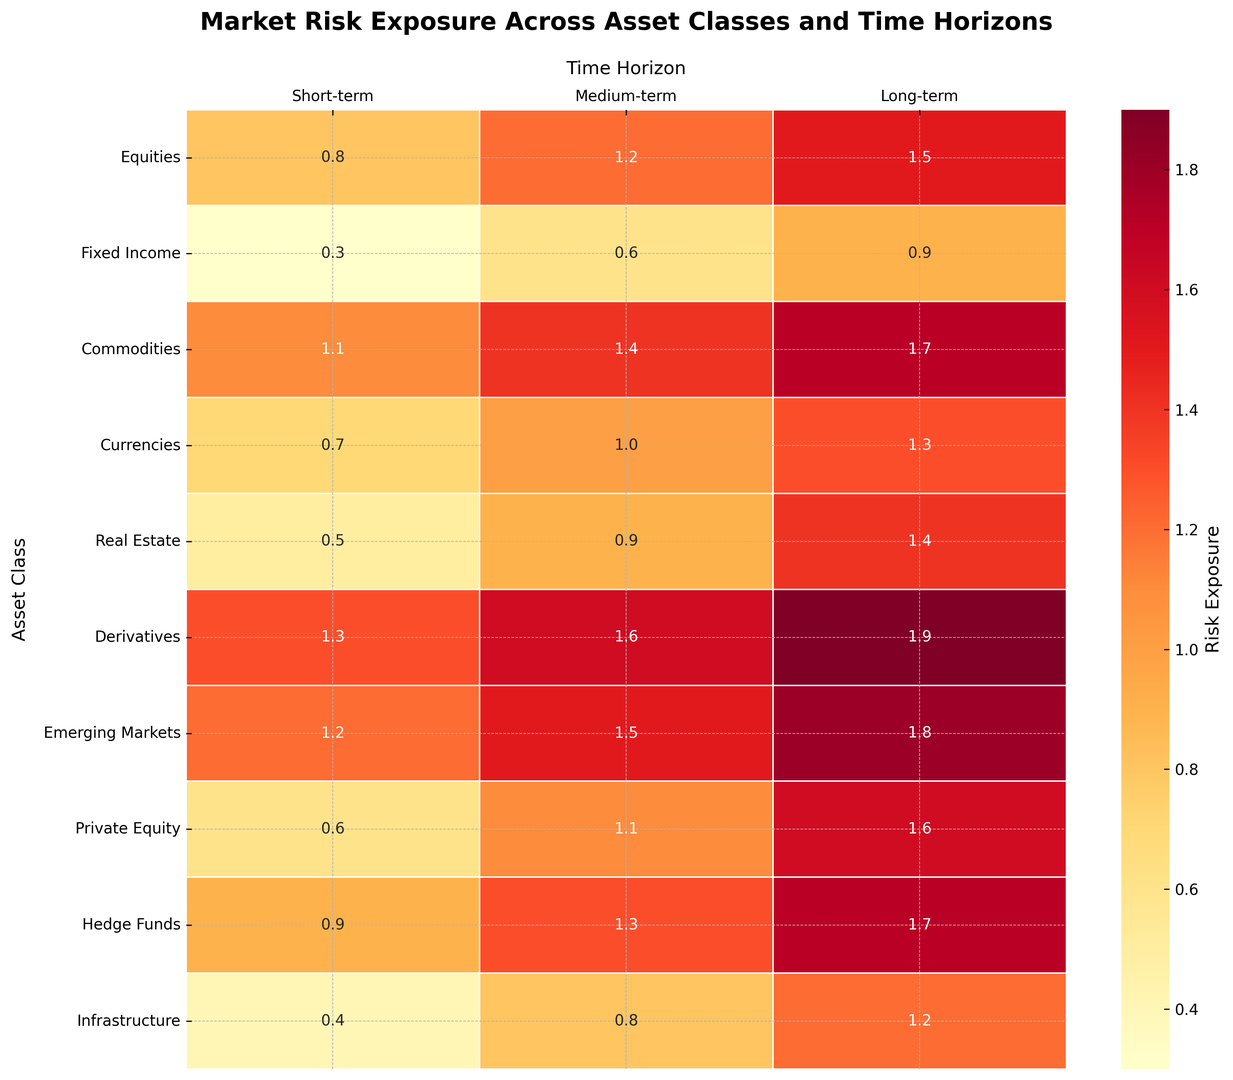What is the highest risk exposure in the long-term horizon? By looking at the "Long-term" column on the heatmap, find the cell with the most intense color. The highest value is in the "Derivatives" row.
Answer: 1.9 Which asset class has the lowest medium-term risk exposure? Refer to the "Medium-term" column and locate the cell with the least intense color. The lowest value is in the "Fixed Income" row.
Answer: Fixed Income How does the short-term risk exposure of Equities compare to that of Fixed Income? Look at the "Short-term" values for "Equities" and "Fixed Income." The values are 0.8 for Equities and 0.3 for Fixed Income, meaning Equities have a higher risk exposure.
Answer: Equities have higher risk exposure What is the average long-term risk exposure for Equities, Commodities, and Derivatives? Add the long-term risk exposures for Equities (1.5), Commodities (1.7), and Derivatives (1.9), and divide by 3. The calculation is (1.5 + 1.7 + 1.9) / 3 = 1.7.
Answer: 1.7 Which time horizon shows the most significant variation in risk exposures across all asset classes? Compare the range of values (maximum - minimum) for each time horizon. The variations are: Short-term (1.3-0.3=1.0), Medium-term (1.6-0.6=1.0), and Long-term (1.9-0.9=1.0). All horizons have the same variation.
Answer: All time horizons have the same variation Which asset class has the most uniform risk exposure across all time horizons? For each asset class, check the consistency of values across all time horizons. Currencies (0.7, 1.0, 1.3) and Real Estate (0.5, 0.9, 1.4) have the most consistent values. Choose one for the answer.
Answer: Currencies What is the total medium-term risk exposure for Real Estate and Hedge Funds combined? Look at the "Medium-term" column. Sum the values for Real Estate (0.9) and Hedge Funds (1.3). The calculation is 0.9 + 1.3 = 2.2.
Answer: 2.2 Between Emerging Markets and Private Equity, which shows a higher risk exposure in the short-term? Compare the "Short-term" values for Emerging Markets (1.2) and Private Equity (0.6). Emerging Markets have higher risk exposure.
Answer: Emerging Markets How does the risk exposure for Infrastructure in the short-term compare to its risk exposure in the long-term? Refer to the "Short-term" and "Long-term" columns for Infrastructure. The values are 0.4 (short-term) and 1.2 (long-term), showing that long-term is higher.
Answer: Long-term is higher What is the difference in long-term risk exposure between Fixed Income and Hedge Funds? Find the "Long-term" values for Fixed Income (0.9) and Hedge Funds (1.7). Subtract the two values, 1.7 - 0.9 = 0.8.
Answer: 0.8 